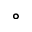<formula> <loc_0><loc_0><loc_500><loc_500>\circ</formula> 